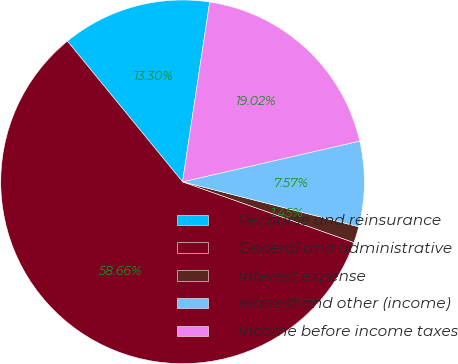Convert chart. <chart><loc_0><loc_0><loc_500><loc_500><pie_chart><fcel>Recourse and reinsurance<fcel>General and administrative<fcel>Interest expense<fcel>Interest and other (income)<fcel>Income before income taxes<nl><fcel>13.3%<fcel>58.66%<fcel>1.45%<fcel>7.57%<fcel>19.02%<nl></chart> 